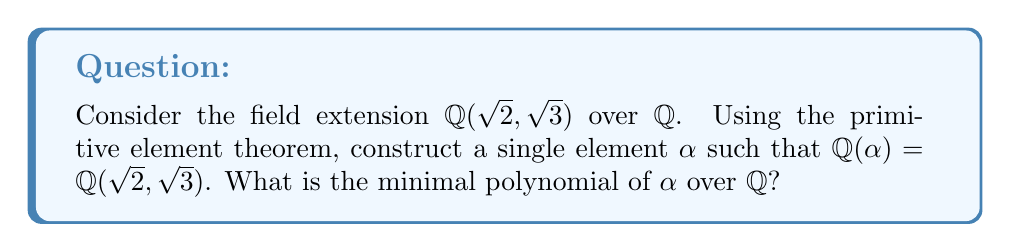Can you solve this math problem? 1. To apply the primitive element theorem, we need to find an element $\alpha = a\sqrt{2} + b\sqrt{3}$ where $a,b \in \mathbb{Q}$ and $a,b \neq 0$.

2. Let's choose $\alpha = \sqrt{2} + \sqrt{3}$ for simplicity.

3. To find the minimal polynomial of $\alpha$, we need to express $\alpha^2, \alpha^3,$ and $\alpha^4$ in terms of $\alpha$:

   $\alpha^2 = (\sqrt{2} + \sqrt{3})^2 = 2 + 3 + 2\sqrt{6} = 5 + 2\sqrt{6}$
   
   $\alpha^3 = (\sqrt{2} + \sqrt{3})(\alpha^2) = (\sqrt{2} + \sqrt{3})(5 + 2\sqrt{6}) = 5\sqrt{2} + 5\sqrt{3} + 2\sqrt{12} + 2\sqrt{18} = 5\sqrt{2} + 5\sqrt{3} + 4\sqrt{3} + 6\sqrt{2} = 11\sqrt{2} + 9\sqrt{3}$
   
   $\alpha^4 = (\alpha^2)^2 = (5 + 2\sqrt{6})^2 = 25 + 20\sqrt{6} + 24 = 49 + 20\sqrt{6}$

4. Now, we can express $\alpha^4$ in terms of lower powers of $\alpha$:

   $\alpha^4 = 49 + 20\sqrt{6} = 49 + 20(\frac{\alpha^2 - 5}{2}) = 49 + 10\alpha^2 - 50 = 10\alpha^2 - 1$

5. Therefore, the minimal polynomial of $\alpha$ over $\mathbb{Q}$ is:

   $p(x) = x^4 - 10x^2 + 1$

This polynomial is irreducible over $\mathbb{Q}$ because it has no rational roots and no quadratic factors.
Answer: $x^4 - 10x^2 + 1$ 